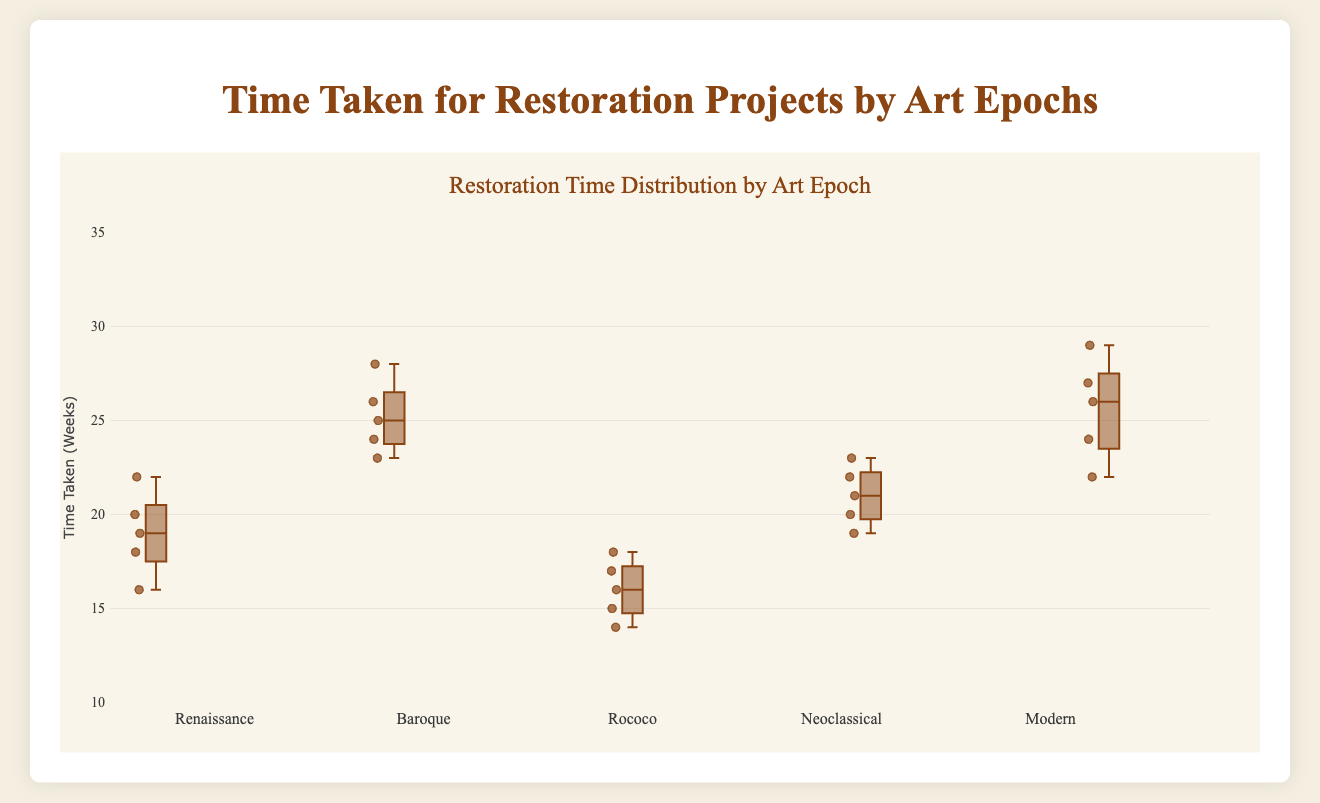What's the title of the box plot? The title is located at the top of the plot and typically provides a summary of the data being visualized. In this case, it reads "Restoration Time Distribution by Art Epoch".
Answer: Restoration Time Distribution by Art Epoch What time duration is on the y-axis? The y-axis of a box plot usually indicates the range of the variable being measured. Here, it shows "Time Taken (Weeks)" with a range from 10 to 35 weeks.
Answer: Time Taken (Weeks) Which epoch has the highest median restoration time? To find the median line within each box, look at the middle line in the plot for each epoch. The 'Modern' epoch shows the highest median line.
Answer: Modern What is the range of restoration times for the Baroque epoch? The range is determined by the minimum and maximum values, represented by the whiskers of the box plot for Baroque epoch. It ranges from 23 to 28 weeks.
Answer: 23 to 28 weeks Compare the interquartile range (IQR) of the Rococo and Neoclassical epochs. Which is larger? The IQR is the box's height in each plot, representing the range between the first quartile (Q1) and the third quartile (Q3). Rococo's IQR appears smaller than Neoclassical's, which spans approximately 19 to 22 weeks.
Answer: Neoclassical Which epoch exhibits the most variability in restoration times? The variability can be inferred from the length of the whiskers and IQR. The 'Modern' epoch shows the most variability with whiskers extending farther than other epochs.
Answer: Modern Are there any epochs with outliers? Outliers are typically indicated by points outside the whiskers. None of the epochs exhibit outliers in this plot.
Answer: No Which epoch has the smallest median restoration time? Observe the median lines within the boxes. The Rococo epoch has the smallest median line among all epochs.
Answer: Rococo How do the median restoration times compare between Renaissance and Baroque epochs? The median lines within the boxes for these epochs show that Baroque's median is above Renaissance's median.
Answer: Baroque is higher than Renaissance Is the distribution of restoration times for the Renaissance paintings symmetric? A symmetric distribution would show that the median line is in the center of the box, and the whiskers are of roughly equal length. The Renaissance distribution appears somewhat symmetric with a slight skew to the right.
Answer: Somewhat symmetric with a slight right skew 